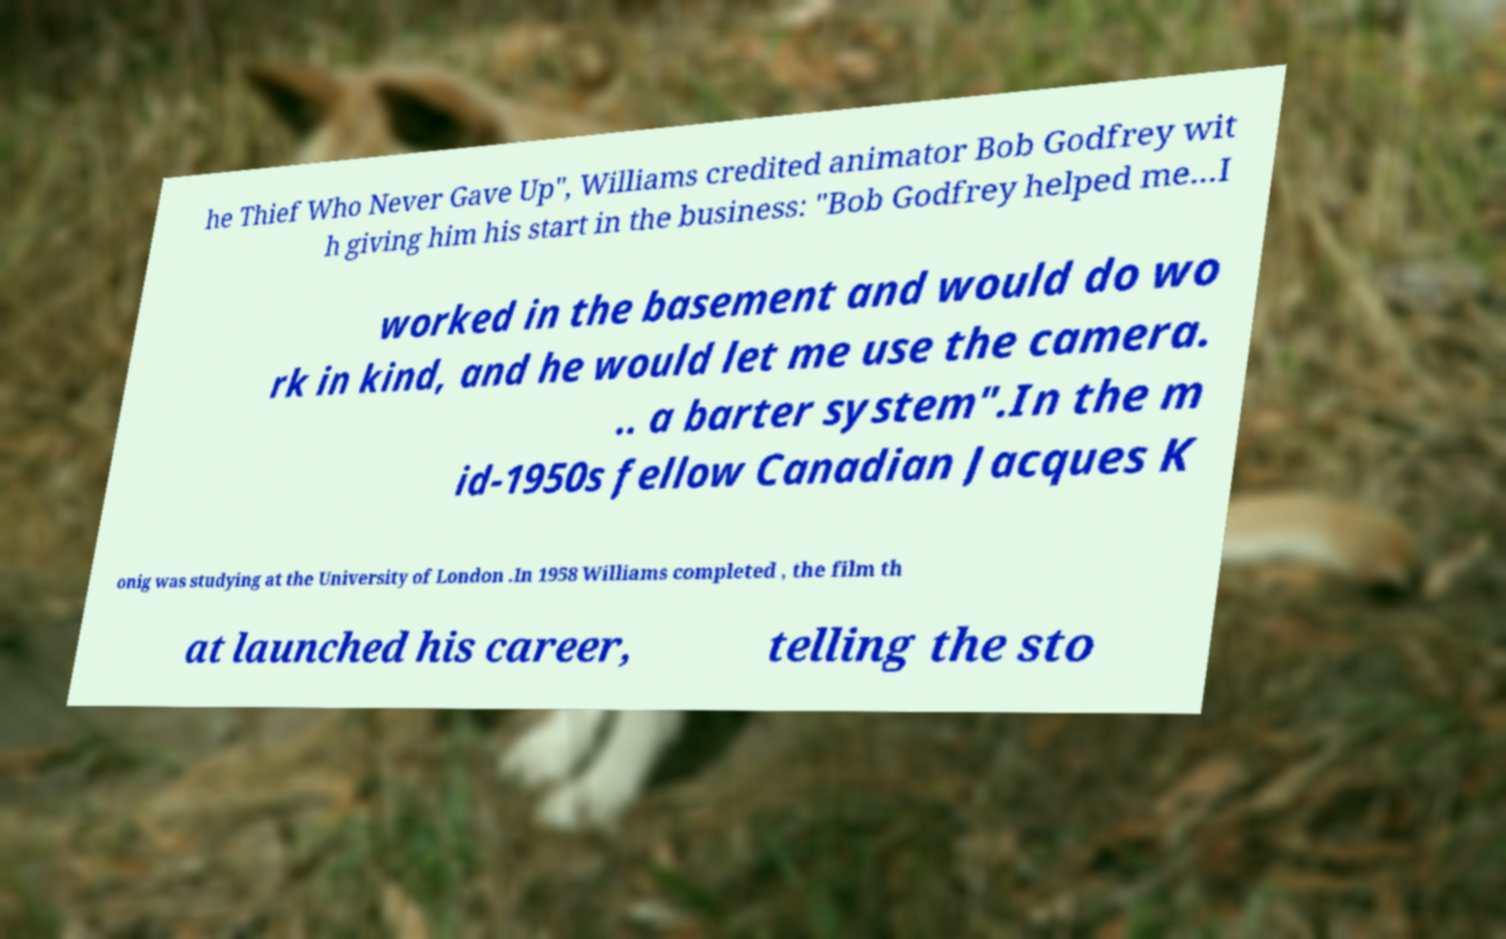Can you accurately transcribe the text from the provided image for me? he Thief Who Never Gave Up", Williams credited animator Bob Godfrey wit h giving him his start in the business: "Bob Godfrey helped me...I worked in the basement and would do wo rk in kind, and he would let me use the camera. .. a barter system".In the m id-1950s fellow Canadian Jacques K onig was studying at the University of London .In 1958 Williams completed , the film th at launched his career, telling the sto 